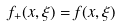Convert formula to latex. <formula><loc_0><loc_0><loc_500><loc_500>f _ { + } ( x , \xi ) = f ( x , \xi )</formula> 